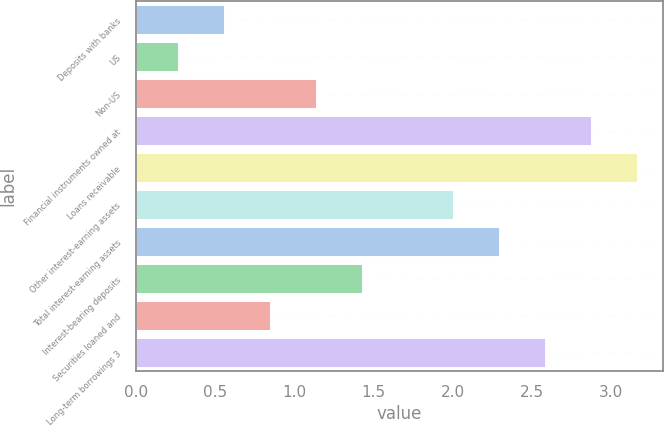Convert chart to OTSL. <chart><loc_0><loc_0><loc_500><loc_500><bar_chart><fcel>Deposits with banks<fcel>US<fcel>Non-US<fcel>Financial instruments owned at<fcel>Loans receivable<fcel>Other interest-earning assets<fcel>Total interest-earning assets<fcel>Interest-bearing deposits<fcel>Securities loaned and<fcel>Long-term borrowings 3<nl><fcel>0.56<fcel>0.27<fcel>1.14<fcel>2.88<fcel>3.17<fcel>2.01<fcel>2.3<fcel>1.43<fcel>0.85<fcel>2.59<nl></chart> 